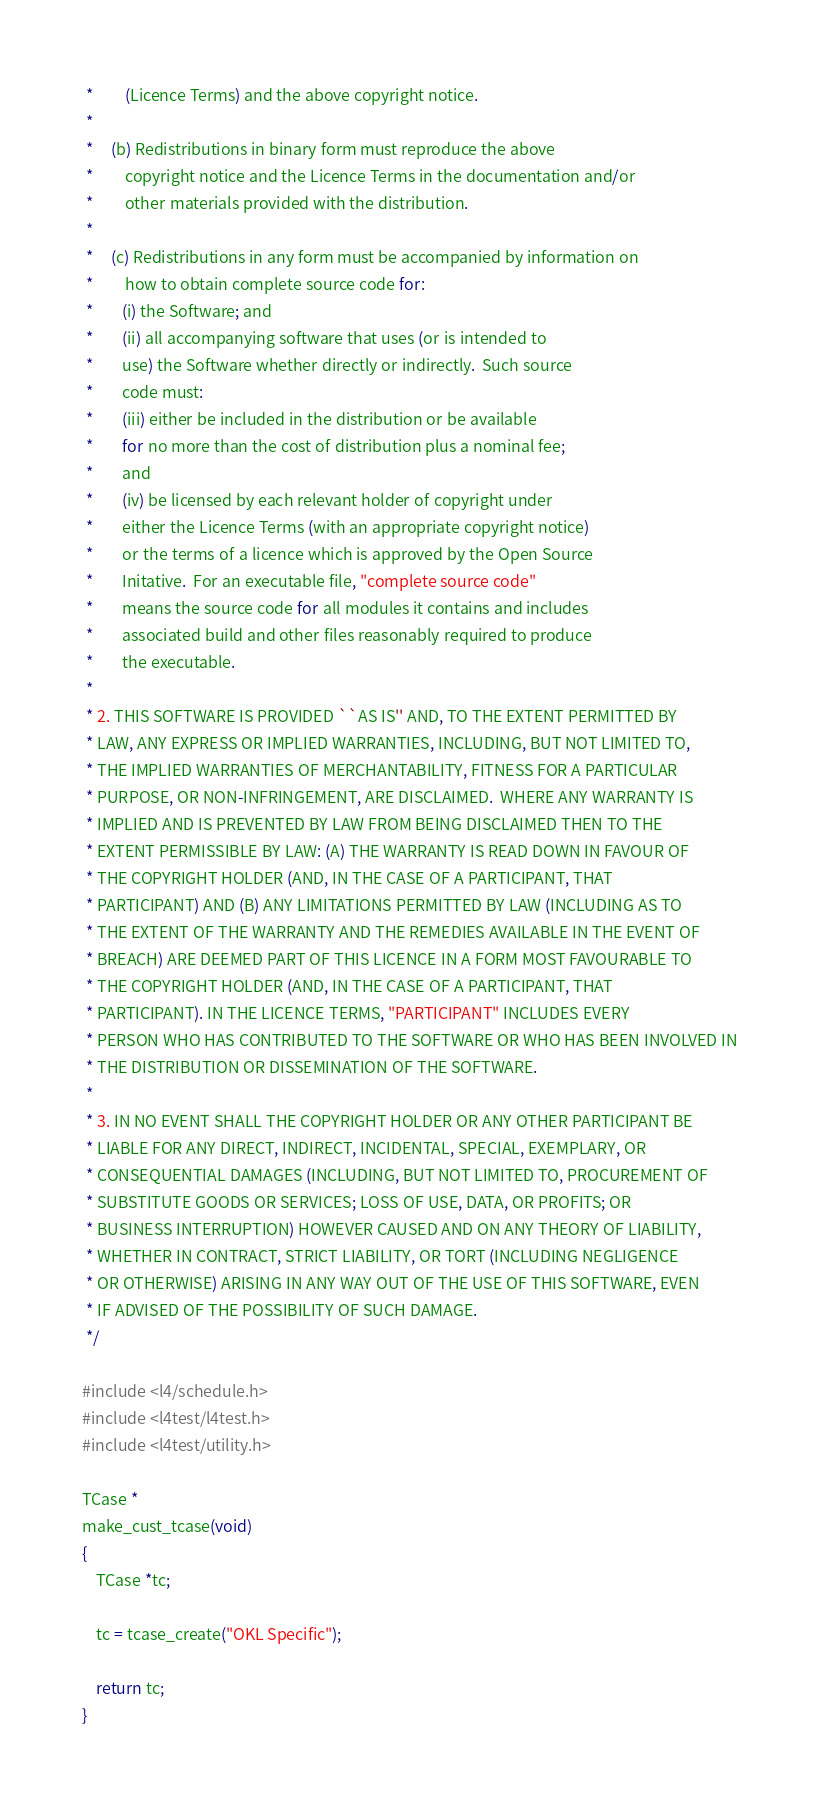<code> <loc_0><loc_0><loc_500><loc_500><_C_> *         (Licence Terms) and the above copyright notice.
 *
 *     (b) Redistributions in binary form must reproduce the above
 *         copyright notice and the Licence Terms in the documentation and/or
 *         other materials provided with the distribution.
 *
 *     (c) Redistributions in any form must be accompanied by information on
 *         how to obtain complete source code for:
 *        (i) the Software; and
 *        (ii) all accompanying software that uses (or is intended to
 *        use) the Software whether directly or indirectly.  Such source
 *        code must:
 *        (iii) either be included in the distribution or be available
 *        for no more than the cost of distribution plus a nominal fee;
 *        and
 *        (iv) be licensed by each relevant holder of copyright under
 *        either the Licence Terms (with an appropriate copyright notice)
 *        or the terms of a licence which is approved by the Open Source
 *        Initative.  For an executable file, "complete source code"
 *        means the source code for all modules it contains and includes
 *        associated build and other files reasonably required to produce
 *        the executable.
 *
 * 2. THIS SOFTWARE IS PROVIDED ``AS IS'' AND, TO THE EXTENT PERMITTED BY
 * LAW, ANY EXPRESS OR IMPLIED WARRANTIES, INCLUDING, BUT NOT LIMITED TO,
 * THE IMPLIED WARRANTIES OF MERCHANTABILITY, FITNESS FOR A PARTICULAR
 * PURPOSE, OR NON-INFRINGEMENT, ARE DISCLAIMED.  WHERE ANY WARRANTY IS
 * IMPLIED AND IS PREVENTED BY LAW FROM BEING DISCLAIMED THEN TO THE
 * EXTENT PERMISSIBLE BY LAW: (A) THE WARRANTY IS READ DOWN IN FAVOUR OF
 * THE COPYRIGHT HOLDER (AND, IN THE CASE OF A PARTICIPANT, THAT
 * PARTICIPANT) AND (B) ANY LIMITATIONS PERMITTED BY LAW (INCLUDING AS TO
 * THE EXTENT OF THE WARRANTY AND THE REMEDIES AVAILABLE IN THE EVENT OF
 * BREACH) ARE DEEMED PART OF THIS LICENCE IN A FORM MOST FAVOURABLE TO
 * THE COPYRIGHT HOLDER (AND, IN THE CASE OF A PARTICIPANT, THAT
 * PARTICIPANT). IN THE LICENCE TERMS, "PARTICIPANT" INCLUDES EVERY
 * PERSON WHO HAS CONTRIBUTED TO THE SOFTWARE OR WHO HAS BEEN INVOLVED IN
 * THE DISTRIBUTION OR DISSEMINATION OF THE SOFTWARE.
 *
 * 3. IN NO EVENT SHALL THE COPYRIGHT HOLDER OR ANY OTHER PARTICIPANT BE
 * LIABLE FOR ANY DIRECT, INDIRECT, INCIDENTAL, SPECIAL, EXEMPLARY, OR
 * CONSEQUENTIAL DAMAGES (INCLUDING, BUT NOT LIMITED TO, PROCUREMENT OF
 * SUBSTITUTE GOODS OR SERVICES; LOSS OF USE, DATA, OR PROFITS; OR
 * BUSINESS INTERRUPTION) HOWEVER CAUSED AND ON ANY THEORY OF LIABILITY,
 * WHETHER IN CONTRACT, STRICT LIABILITY, OR TORT (INCLUDING NEGLIGENCE
 * OR OTHERWISE) ARISING IN ANY WAY OUT OF THE USE OF THIS SOFTWARE, EVEN
 * IF ADVISED OF THE POSSIBILITY OF SUCH DAMAGE.
 */

#include <l4/schedule.h>
#include <l4test/l4test.h>
#include <l4test/utility.h>

TCase *
make_cust_tcase(void)
{
    TCase *tc;

    tc = tcase_create("OKL Specific");

    return tc;
}
</code> 